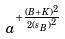Convert formula to latex. <formula><loc_0><loc_0><loc_500><loc_500>a ^ { + \frac { ( B + K ) ^ { 2 } } { 2 { ( s _ { B } ) } ^ { 2 } } }</formula> 